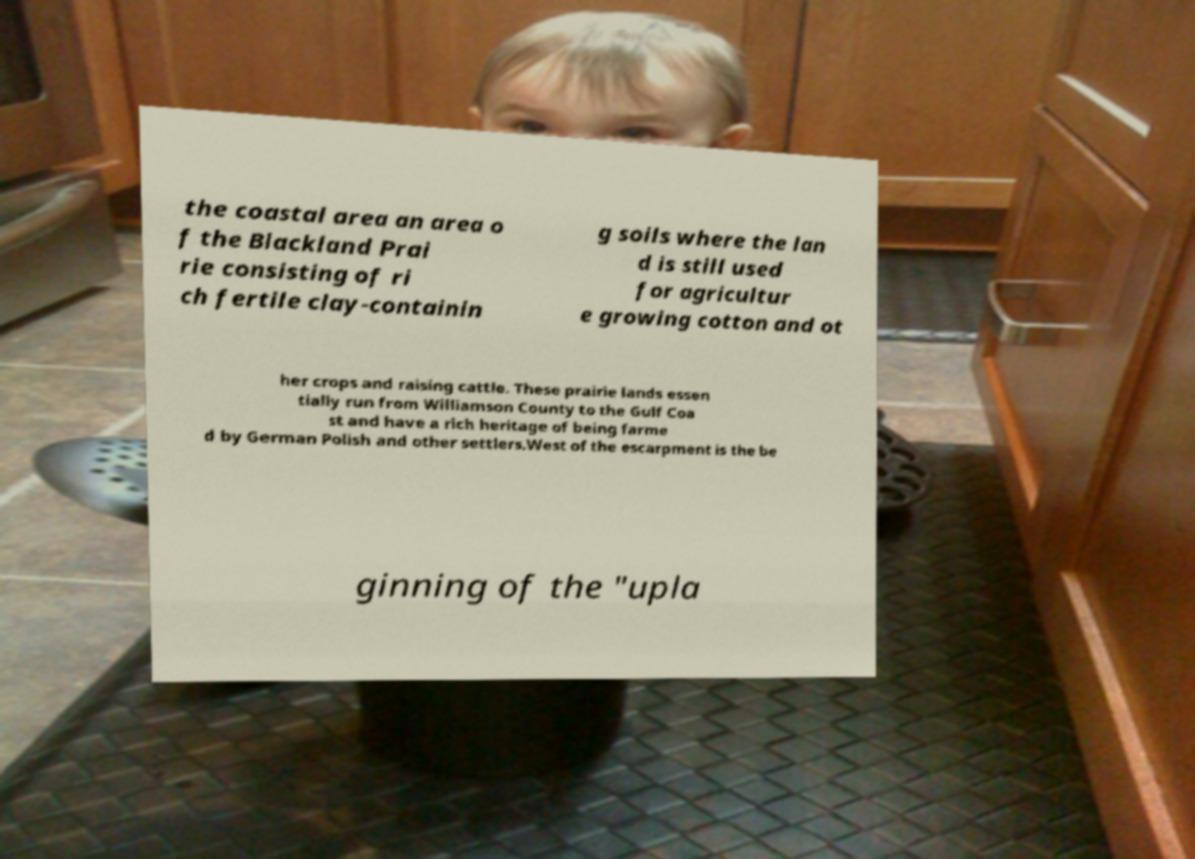There's text embedded in this image that I need extracted. Can you transcribe it verbatim? the coastal area an area o f the Blackland Prai rie consisting of ri ch fertile clay-containin g soils where the lan d is still used for agricultur e growing cotton and ot her crops and raising cattle. These prairie lands essen tially run from Williamson County to the Gulf Coa st and have a rich heritage of being farme d by German Polish and other settlers.West of the escarpment is the be ginning of the "upla 